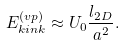<formula> <loc_0><loc_0><loc_500><loc_500>E _ { k i n k } ^ { ( v p ) } \approx U _ { 0 } \frac { l _ { 2 D } } { a ^ { 2 } } .</formula> 